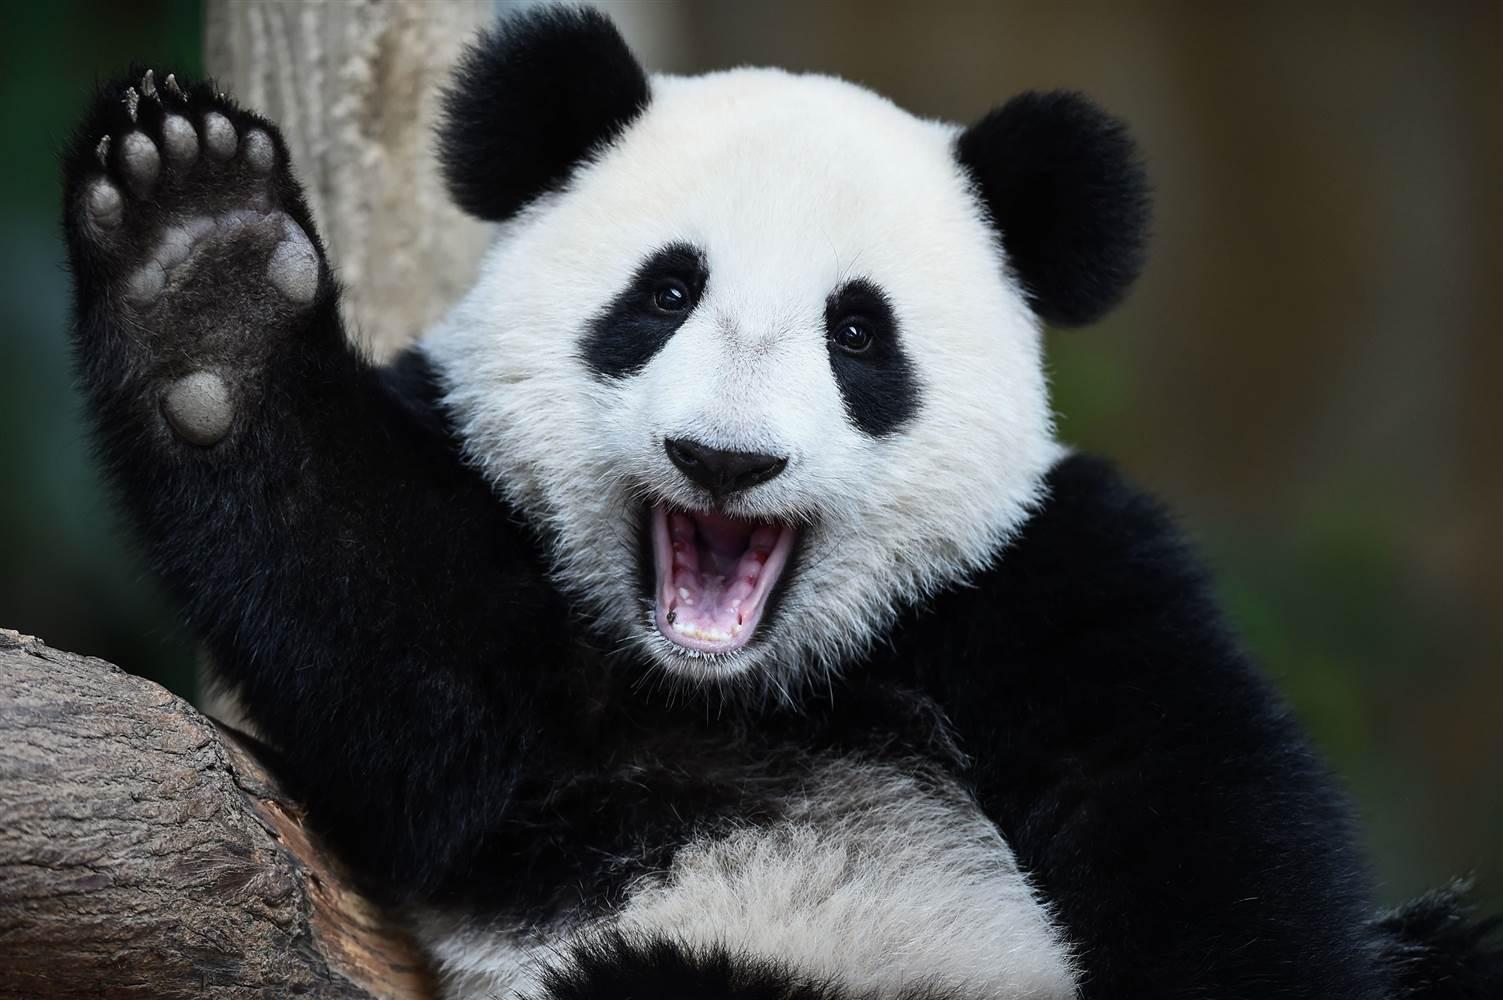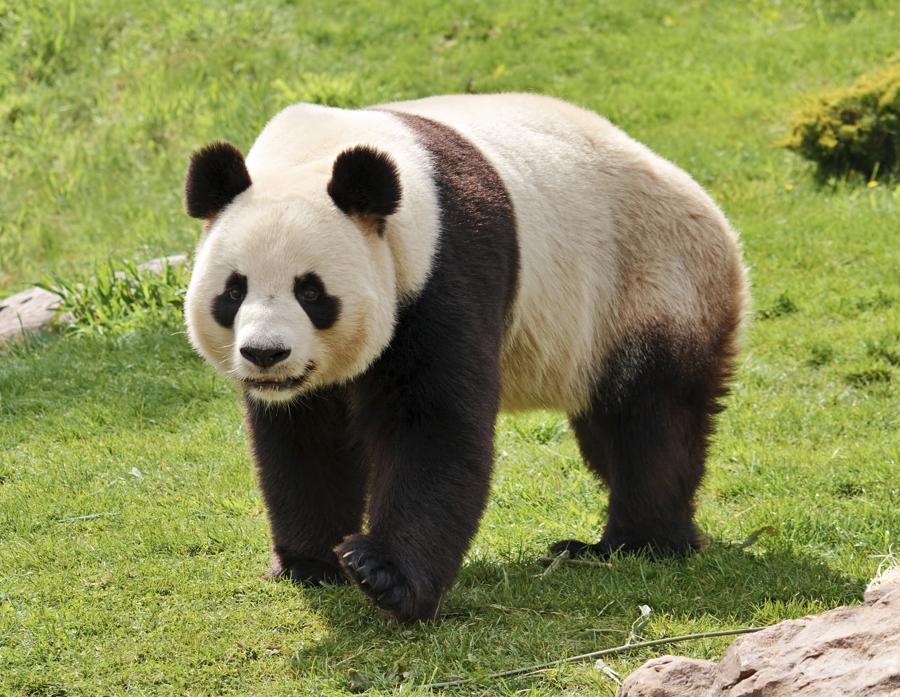The first image is the image on the left, the second image is the image on the right. For the images shown, is this caption "There are two black and white panda bears" true? Answer yes or no. Yes. The first image is the image on the left, the second image is the image on the right. For the images displayed, is the sentence "One of the pandas is on all fours." factually correct? Answer yes or no. Yes. 